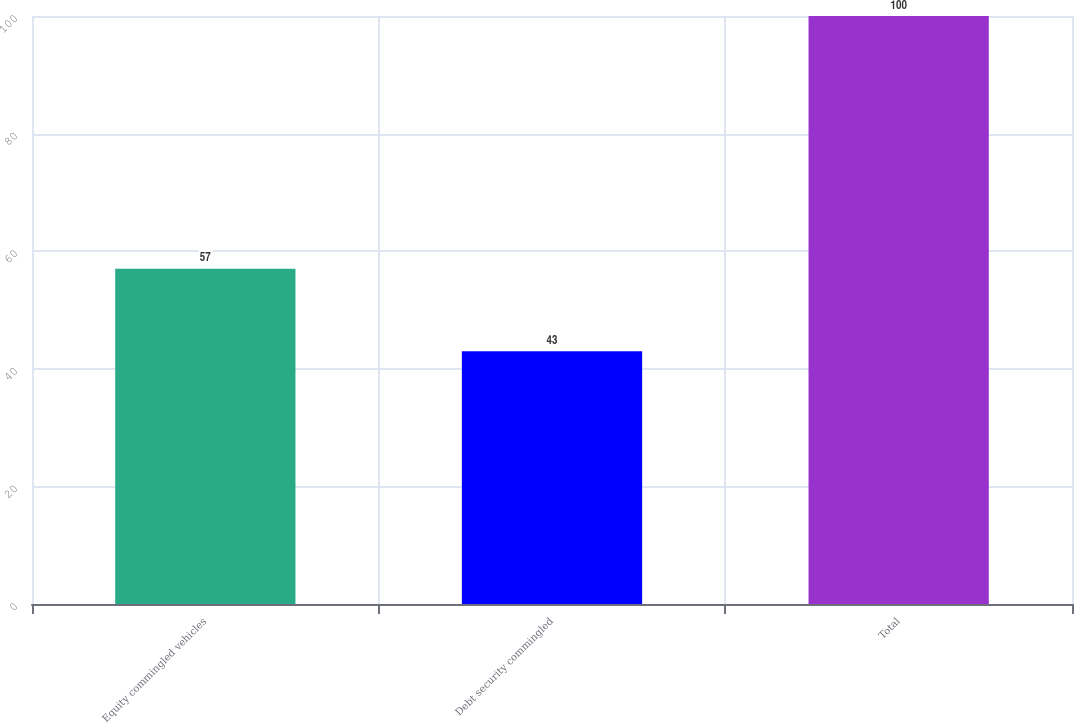Convert chart. <chart><loc_0><loc_0><loc_500><loc_500><bar_chart><fcel>Equity commingled vehicles<fcel>Debt security commingled<fcel>Total<nl><fcel>57<fcel>43<fcel>100<nl></chart> 